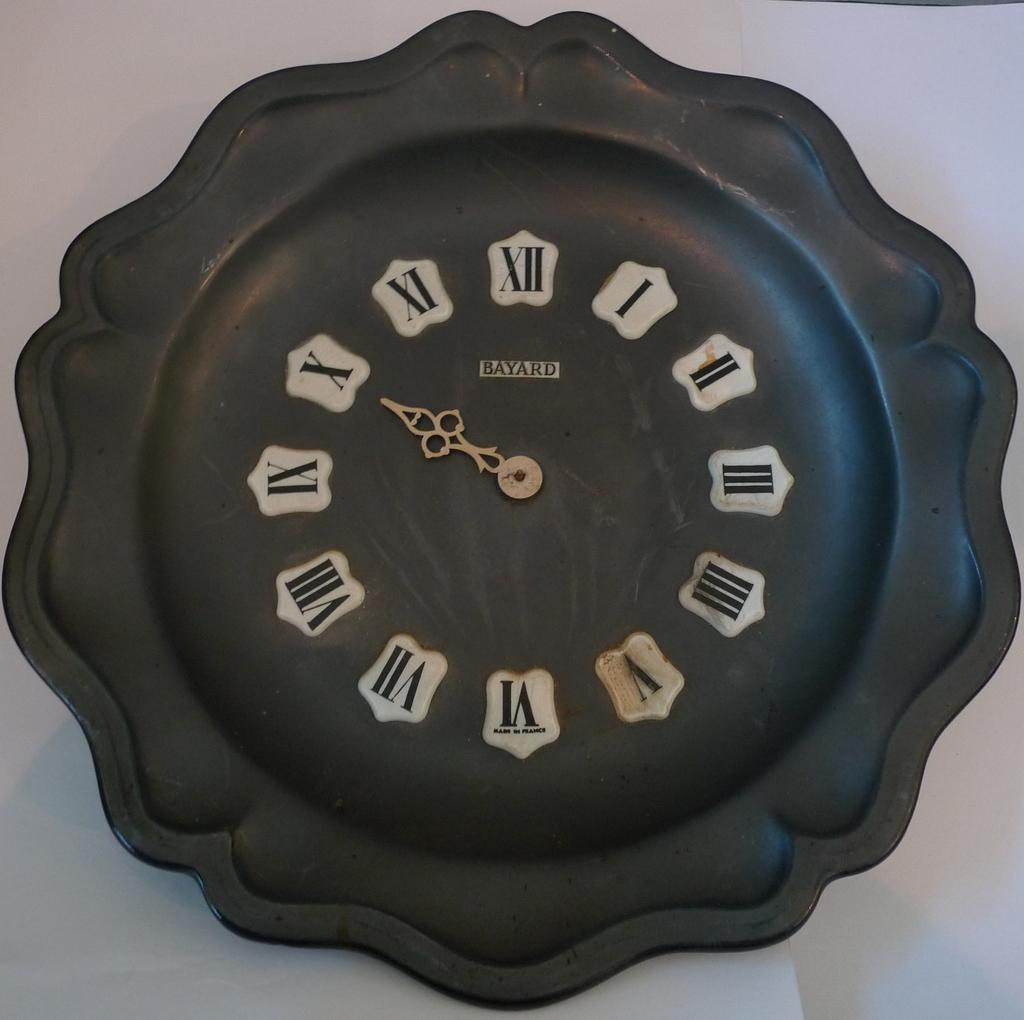Provide a one-sentence caption for the provided image. A unique black clocked filled with silver-played numbers and a gold hand. 